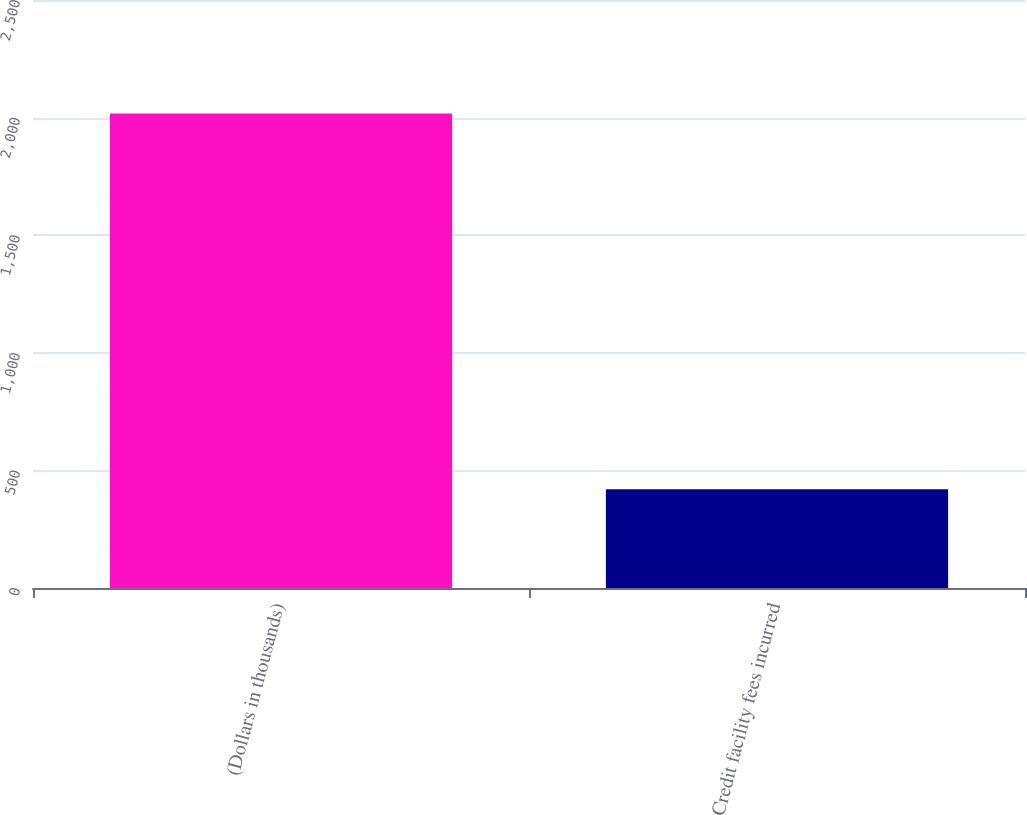Convert chart to OTSL. <chart><loc_0><loc_0><loc_500><loc_500><bar_chart><fcel>(Dollars in thousands)<fcel>Credit facility fees incurred<nl><fcel>2017<fcel>420<nl></chart> 